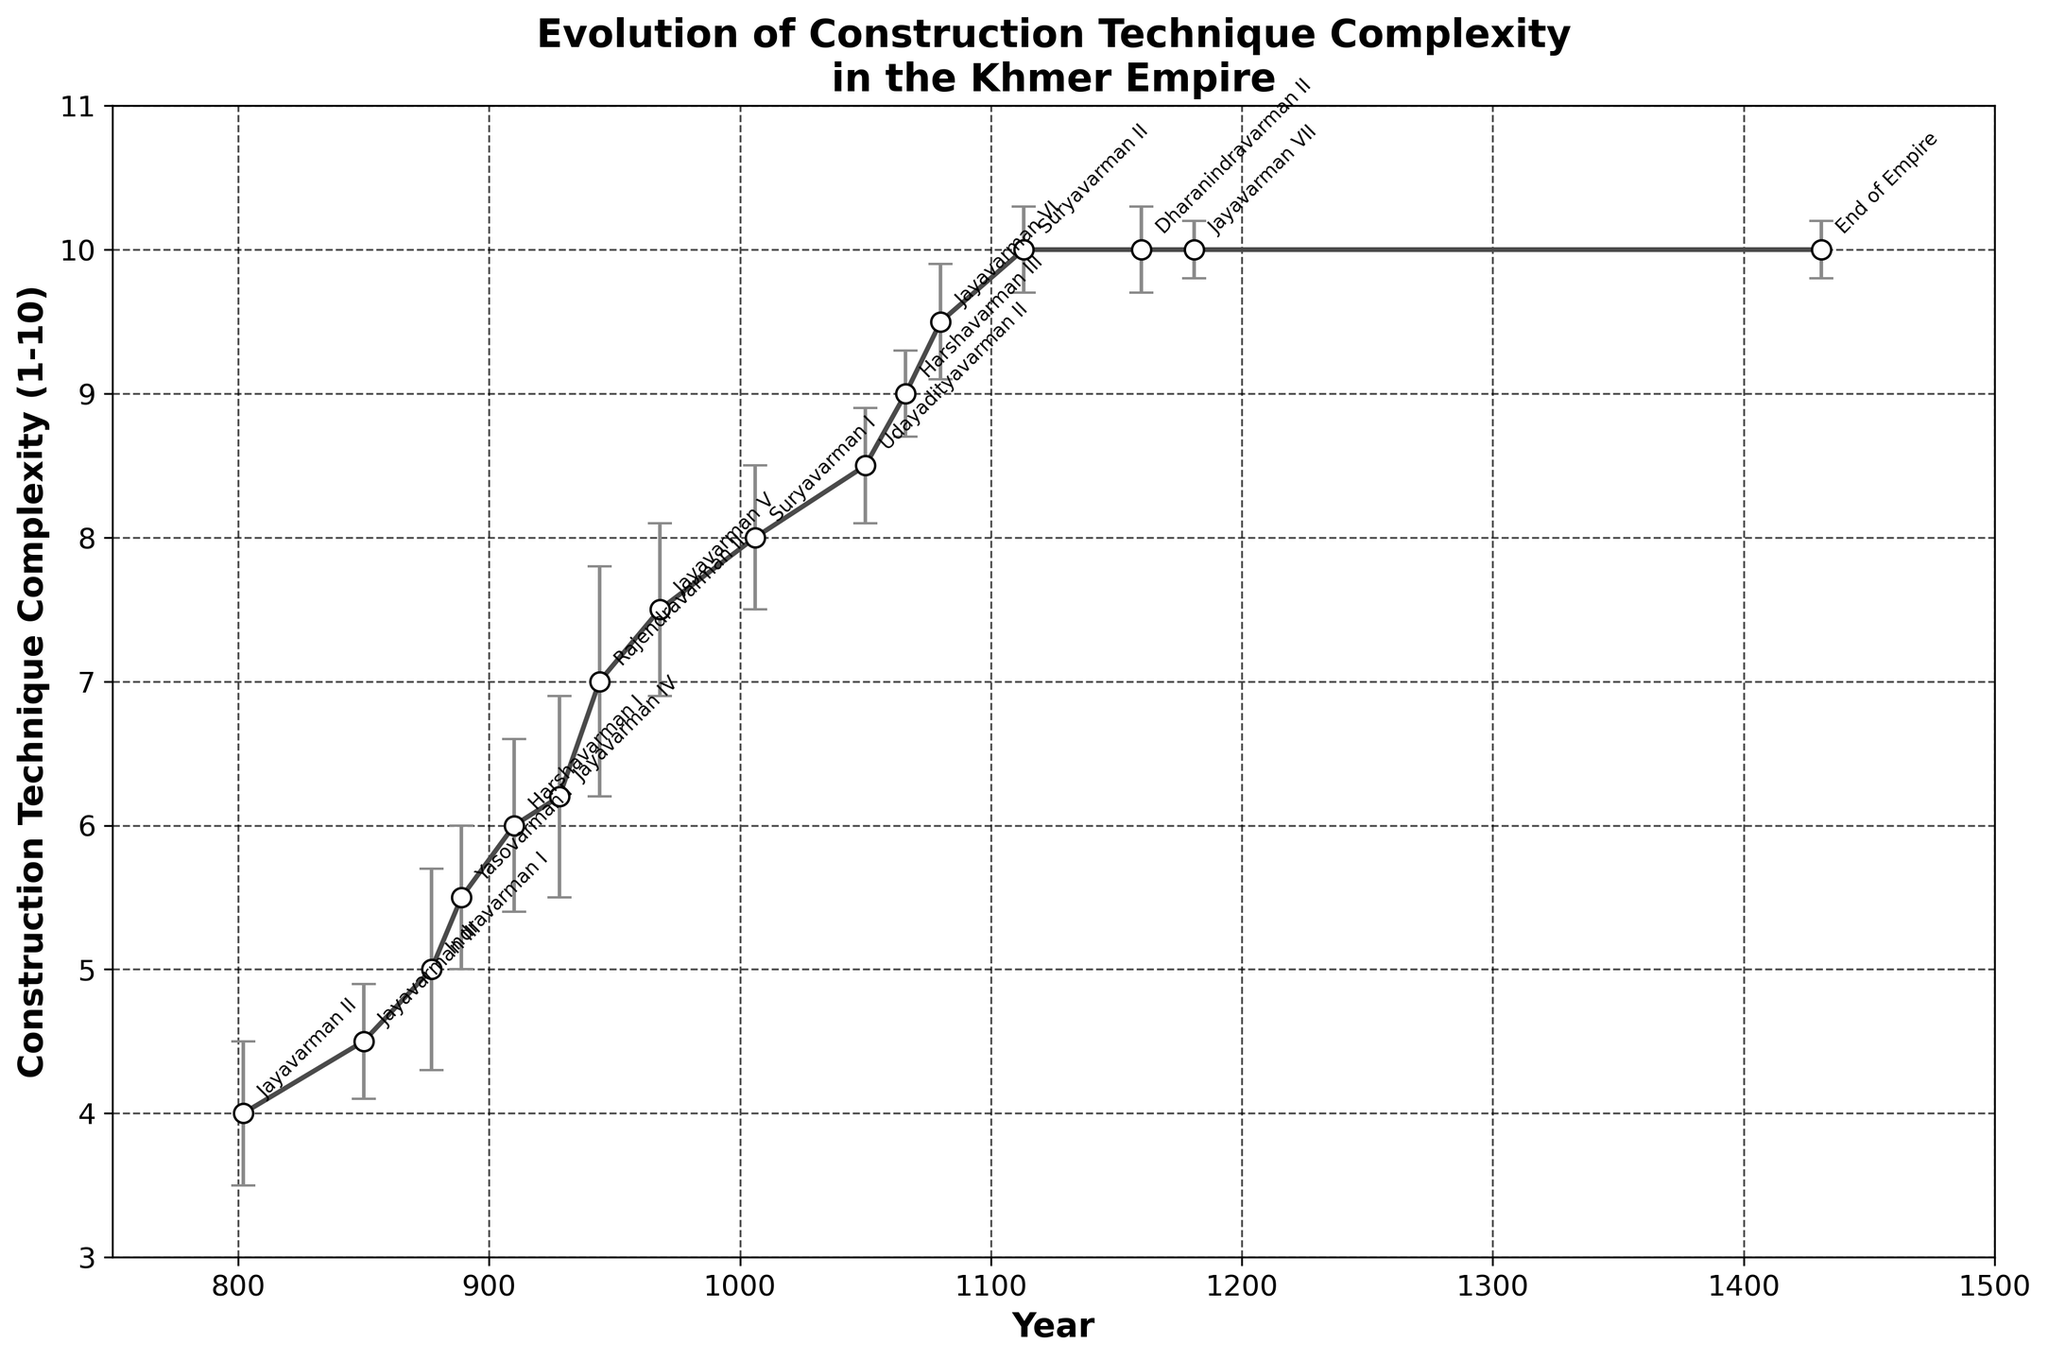What is the title of the figure? The title of the figure is usually displayed at the top of the plot. It directly indicates the main subject of the figure.
Answer: Evolution of Construction Technique Complexity in the Khmer Empire What is the y-axis representing in the figure? The y-axis label can be found on the side of the plot. It specifies the type of data being shown.
Answer: Construction Technique Complexity (1-10) Over which years does the plot span? The x-axis represents the years, and by looking at the minimum and maximum values on this axis, we can determine the span. The first year marked is 802, and the last year is 1431.
Answer: 802 to 1431 Which reign had the maximum complexity in construction techniques? By examining the highest data point on the plot, we can identify which reign corresponds to this value. Multiple reigns reach the value of 10 in the latter half.
Answer: Several, including Suryavarman II and Jayavarman VII How does the complexity of construction techniques change from Jayavarman II's reign to the end of the empire? Look at the data points for Jayavarman II and the end of the empire. Note the first and last values on the y-axis. The complexity increases from about 4 to 10 over time.
Answer: Increased significantly What is the average construction technique complexity during the reigns of Suryavarman I and Udayadityavarman II? Find the values corresponding to these two reigns and calculate their average. Suryavarman I has a complexity of 8 and Udayadityavarman II has 8.5. The average is (8 + 8.5) / 2.
Answer: 8.25 Which reign shows the largest improvement in construction technique complexity compared to its predecessor? Identify changes between successive data points, focusing on rises in the y-axis value. The largest change is between Rajendravarman II (7) and Jayavarman V (7.5).
Answer: Jayavarman V Describe the trend in the error bars for the construction technique complexity over the years. Observe the lengths of the error bars as you move from left to right in the plot. The error bars generally decrease, indicating increasing precision in the complexity measurement.
Answer: Decreasing What is the difference in construction technique complexity between Indravarman I and Jayavarman VII? Identify the y-values for both reigns and find their difference. Indravarman I has a value of 5, and Jayavarman VII has 10.
Answer: 5 